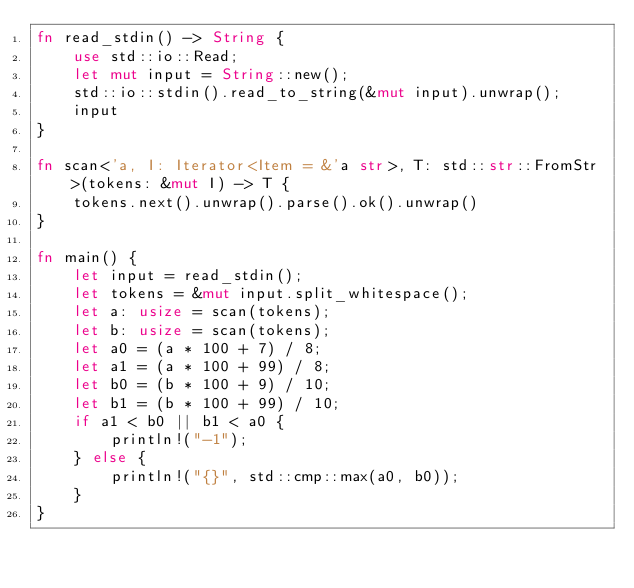<code> <loc_0><loc_0><loc_500><loc_500><_Rust_>fn read_stdin() -> String {
    use std::io::Read;
    let mut input = String::new();
    std::io::stdin().read_to_string(&mut input).unwrap();
    input
}

fn scan<'a, I: Iterator<Item = &'a str>, T: std::str::FromStr>(tokens: &mut I) -> T {
    tokens.next().unwrap().parse().ok().unwrap()
}

fn main() {
    let input = read_stdin();
    let tokens = &mut input.split_whitespace();
    let a: usize = scan(tokens);
    let b: usize = scan(tokens);
    let a0 = (a * 100 + 7) / 8;
    let a1 = (a * 100 + 99) / 8;
    let b0 = (b * 100 + 9) / 10;
    let b1 = (b * 100 + 99) / 10;
    if a1 < b0 || b1 < a0 {
        println!("-1");
    } else {
        println!("{}", std::cmp::max(a0, b0));
    }
}
</code> 